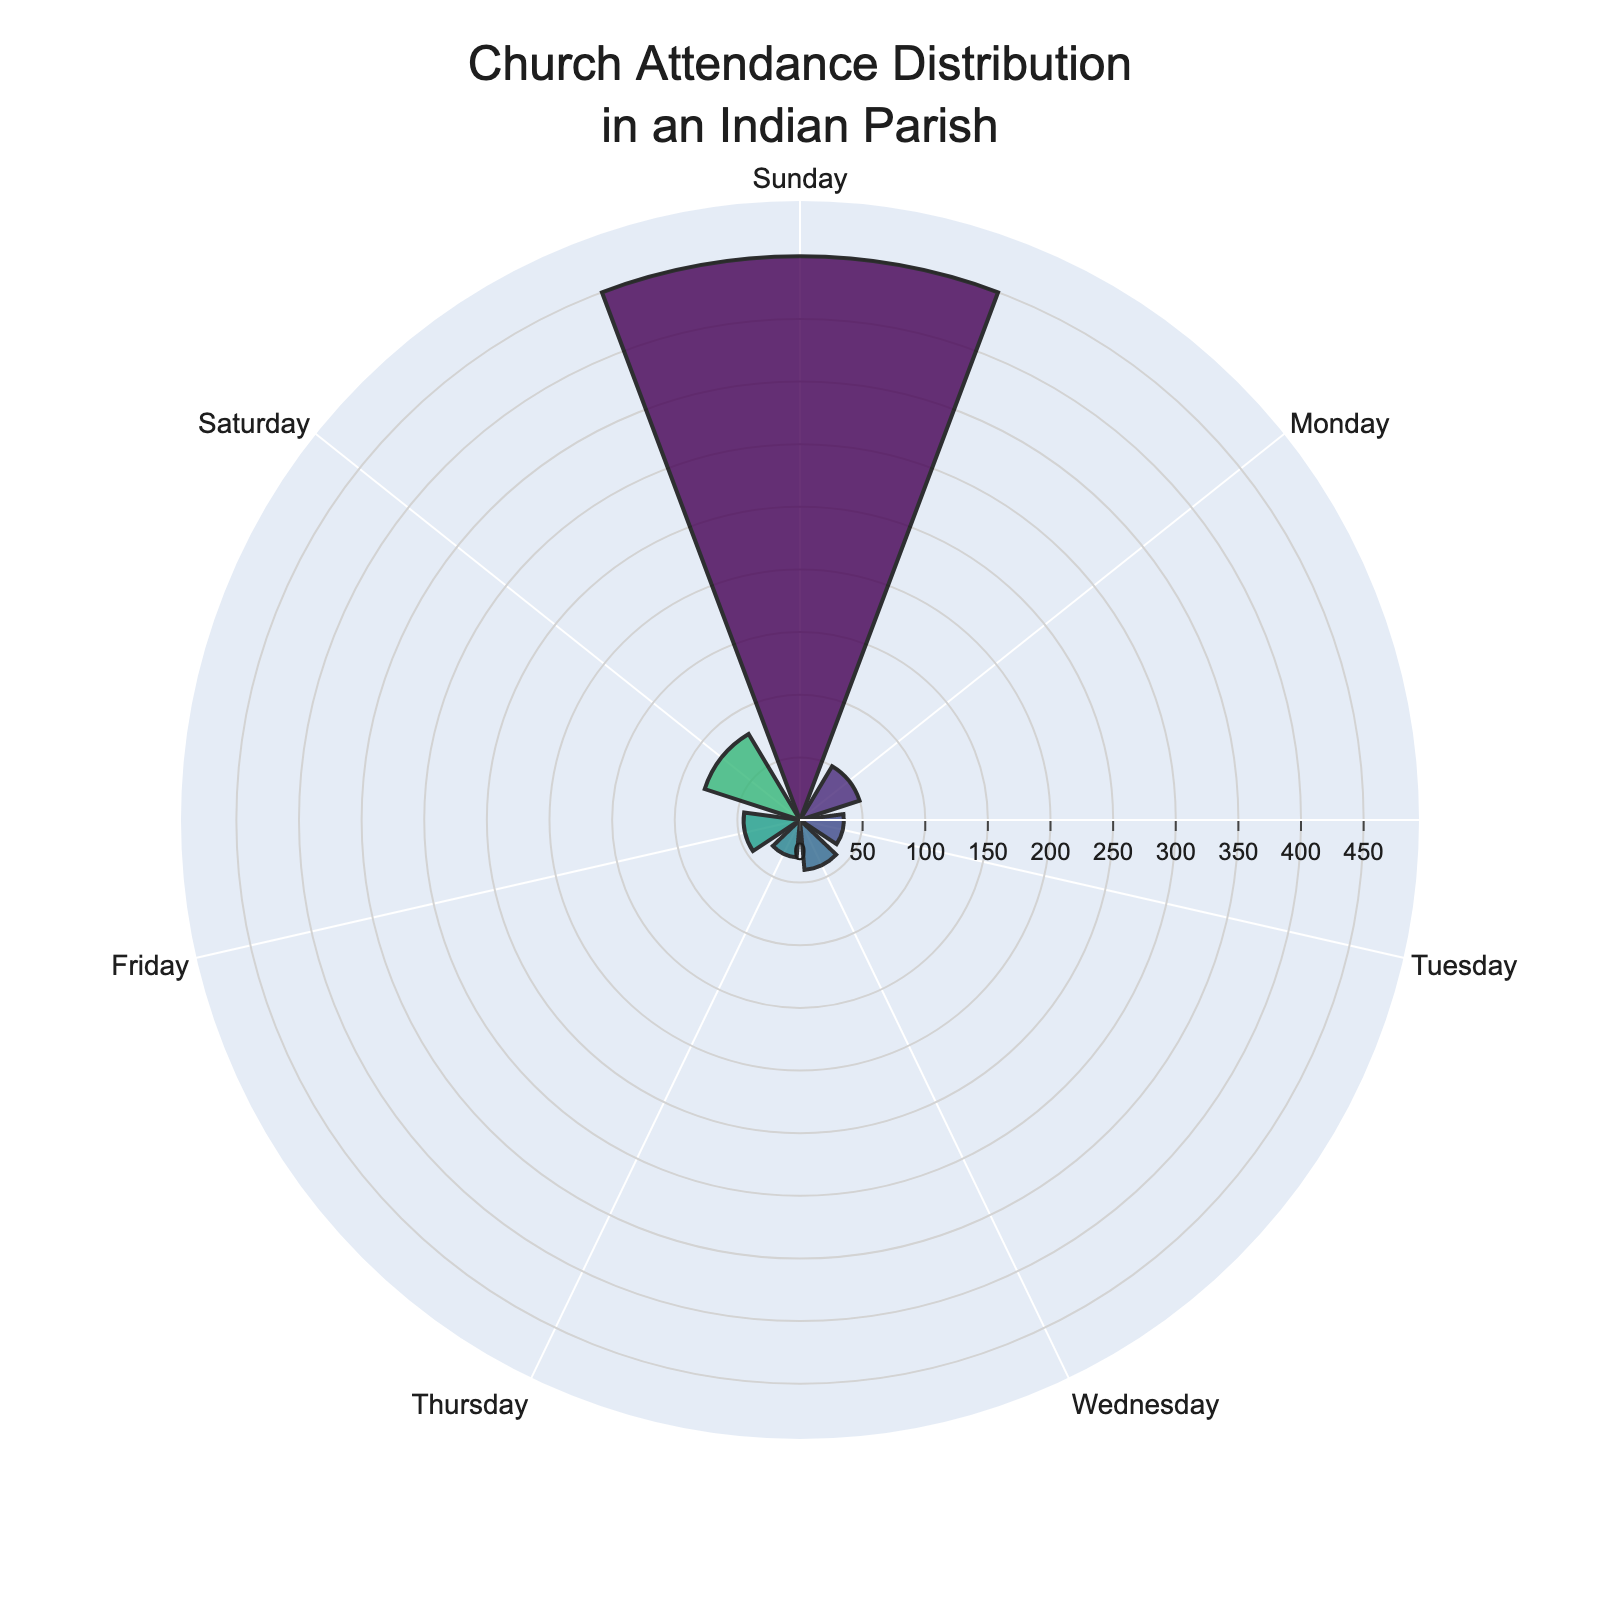What is the title of the plot? The title is found at the top center of the plot. It should describe what the chart represents.
Answer: Church Attendance Distribution in an Indian Parish Which day of the week has the highest church attendance? Observe the length of the bars representing the days. The longest bar indicates the highest attendance.
Answer: Sunday How does the attendance on Friday compare to that on Monday? Compare the length of the bars for Friday and Monday. The longer bar indicates higher attendance.
Answer: Monday has slightly higher attendance What is the total church attendance for the entire week? Add up the attendance for each day of the week: 450 + 50 + 35 + 40 + 30 + 45 + 80.
Answer: 730 On which day is the church least attended? Identify the shortest bar, which represents the lowest attendance.
Answer: Thursday What is the average church attendance per day? Find the total attendance for the week (730) and divide by 7 (the number of days).
Answer: 104.3 (rounded off to 1 decimal place) Which days have attendance greater than 50? Compare each bar's length to the marker representing 50. Identify those that are higher.
Answer: Sunday, Saturday How does Saturday’s attendance compare to Tuesday’s attendance? Check the bars and observe that the bar for Saturday is longer than for Tuesday.
Answer: Saturday's attendance is higher What is the difference in attendance between Sunday and Wednesday? Subtract the attendance of Wednesday from that of Sunday: 450 - 40.
Answer: 410 Which two consecutive days have the most similar attendance counts? Look for bars of similar lengths that are next to each other in the sequence.
Answer: Monday and Friday What is the attendance trend from Monday to Thursday? Observe the change in bar lengths from Monday to Thursday. Attendance generally shows a decreasing trend.
Answer: Decreasing 